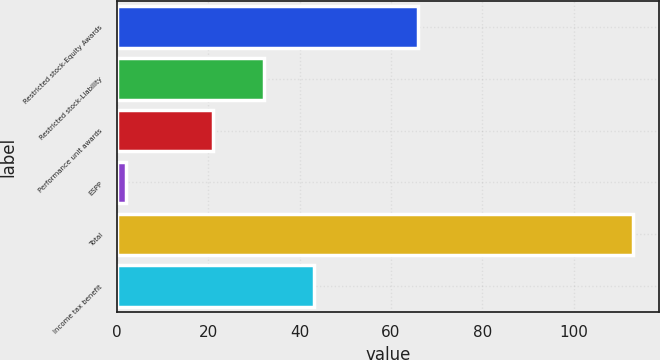<chart> <loc_0><loc_0><loc_500><loc_500><bar_chart><fcel>Restricted stock-Equity Awards<fcel>Restricted stock-Liability<fcel>Performance unit awards<fcel>ESPP<fcel>Total<fcel>Income tax benefit<nl><fcel>66<fcel>32.1<fcel>21<fcel>2<fcel>113<fcel>43.2<nl></chart> 